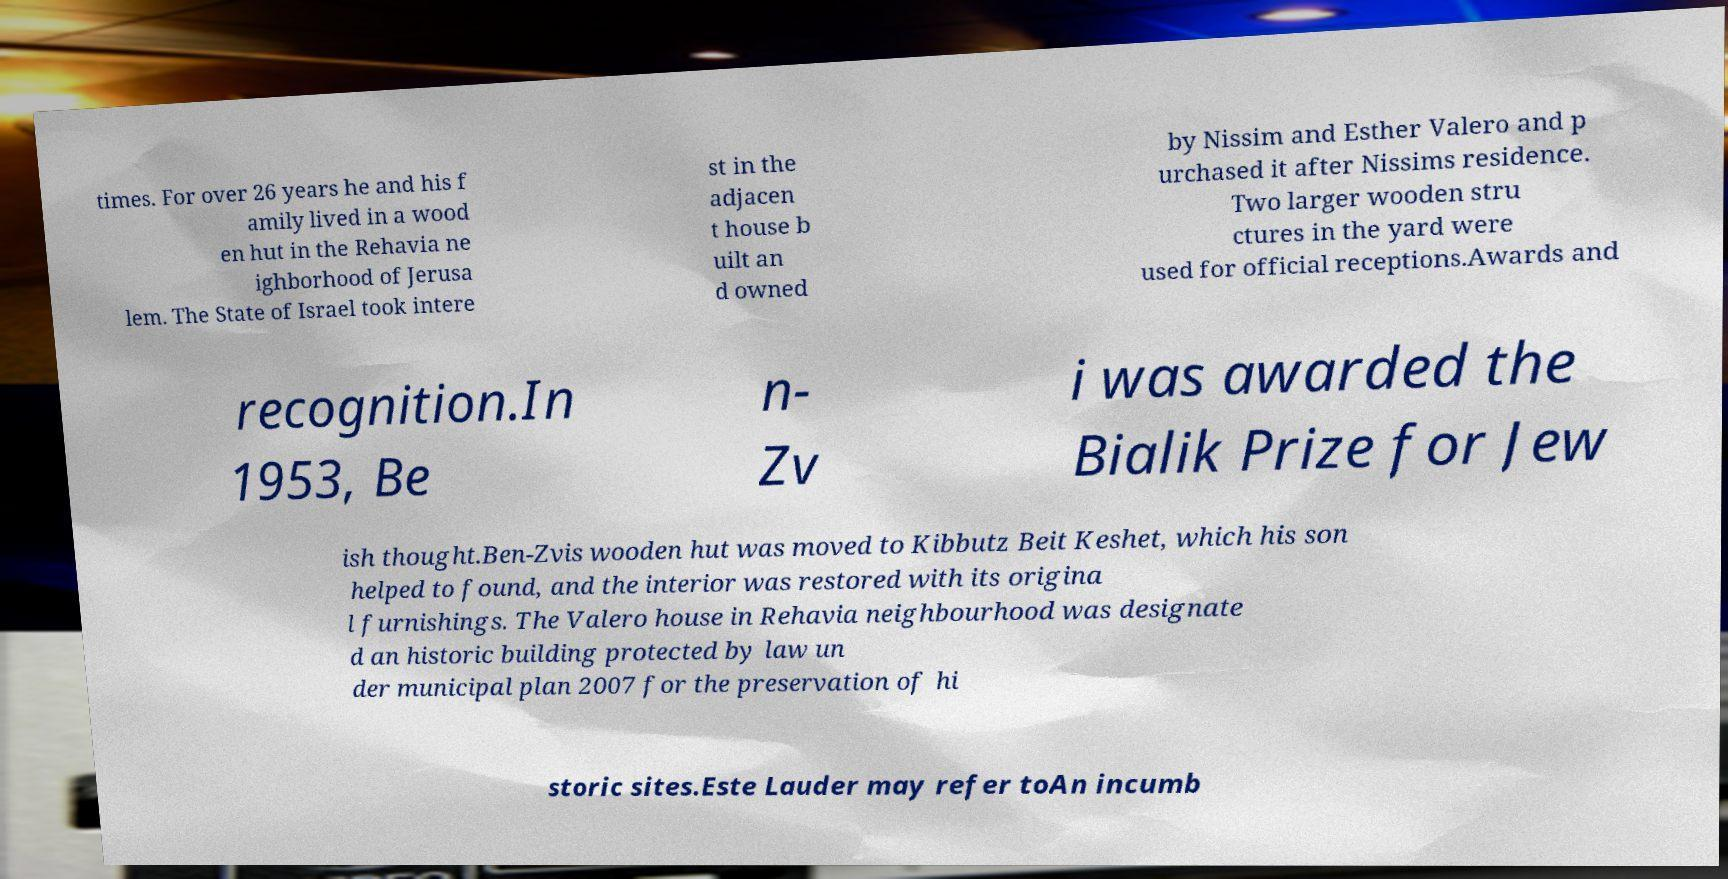Please read and relay the text visible in this image. What does it say? times. For over 26 years he and his f amily lived in a wood en hut in the Rehavia ne ighborhood of Jerusa lem. The State of Israel took intere st in the adjacen t house b uilt an d owned by Nissim and Esther Valero and p urchased it after Nissims residence. Two larger wooden stru ctures in the yard were used for official receptions.Awards and recognition.In 1953, Be n- Zv i was awarded the Bialik Prize for Jew ish thought.Ben-Zvis wooden hut was moved to Kibbutz Beit Keshet, which his son helped to found, and the interior was restored with its origina l furnishings. The Valero house in Rehavia neighbourhood was designate d an historic building protected by law un der municipal plan 2007 for the preservation of hi storic sites.Este Lauder may refer toAn incumb 